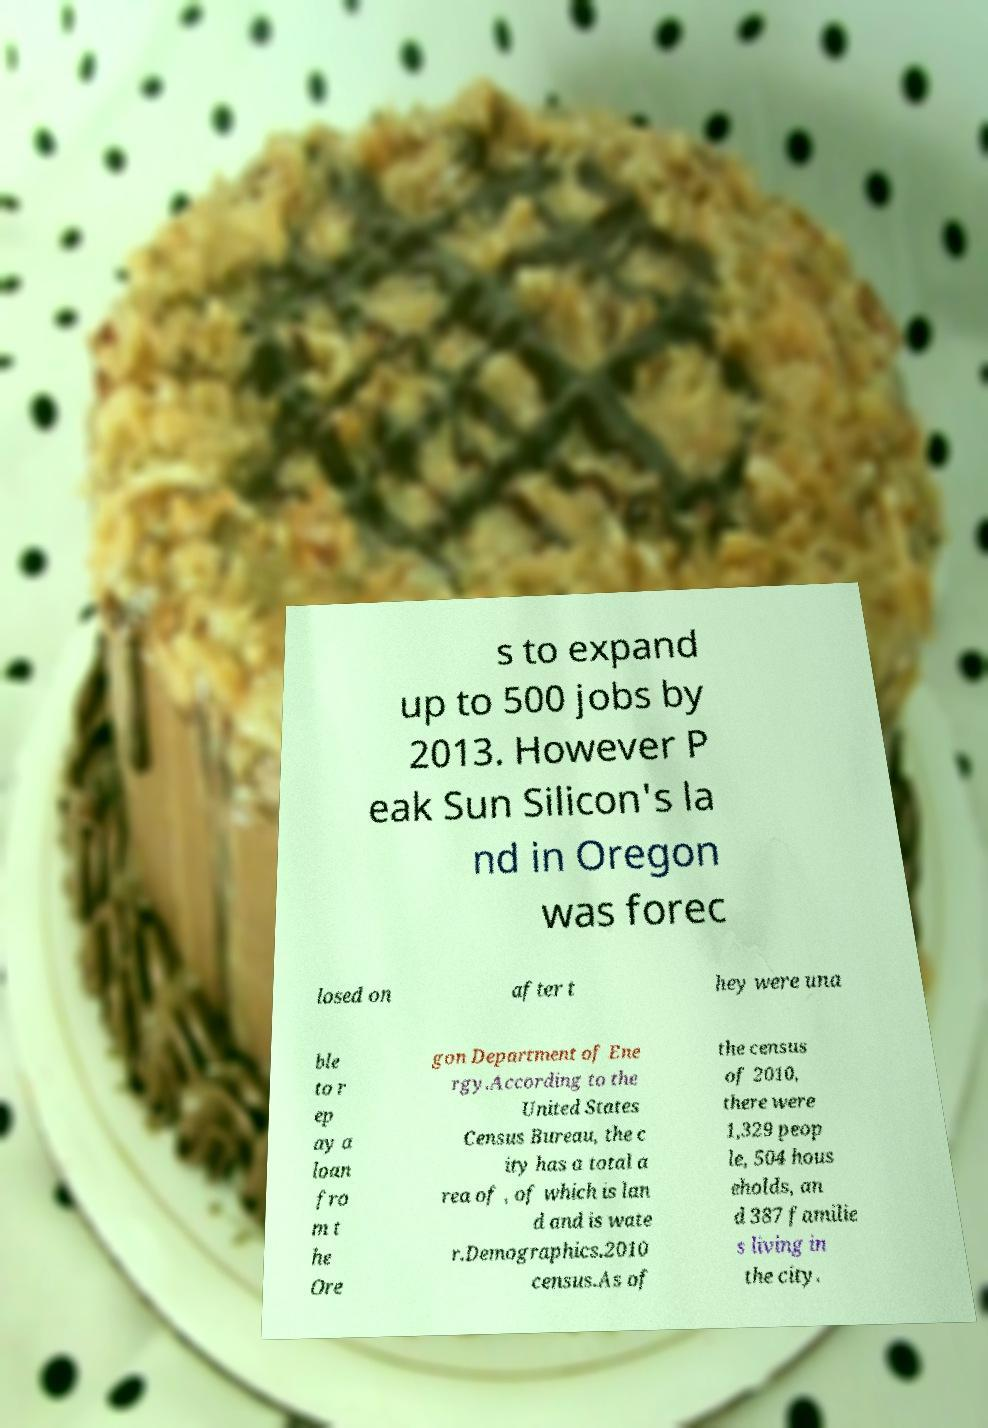Please read and relay the text visible in this image. What does it say? s to expand up to 500 jobs by 2013. However P eak Sun Silicon's la nd in Oregon was forec losed on after t hey were una ble to r ep ay a loan fro m t he Ore gon Department of Ene rgy.According to the United States Census Bureau, the c ity has a total a rea of , of which is lan d and is wate r.Demographics.2010 census.As of the census of 2010, there were 1,329 peop le, 504 hous eholds, an d 387 familie s living in the city. 